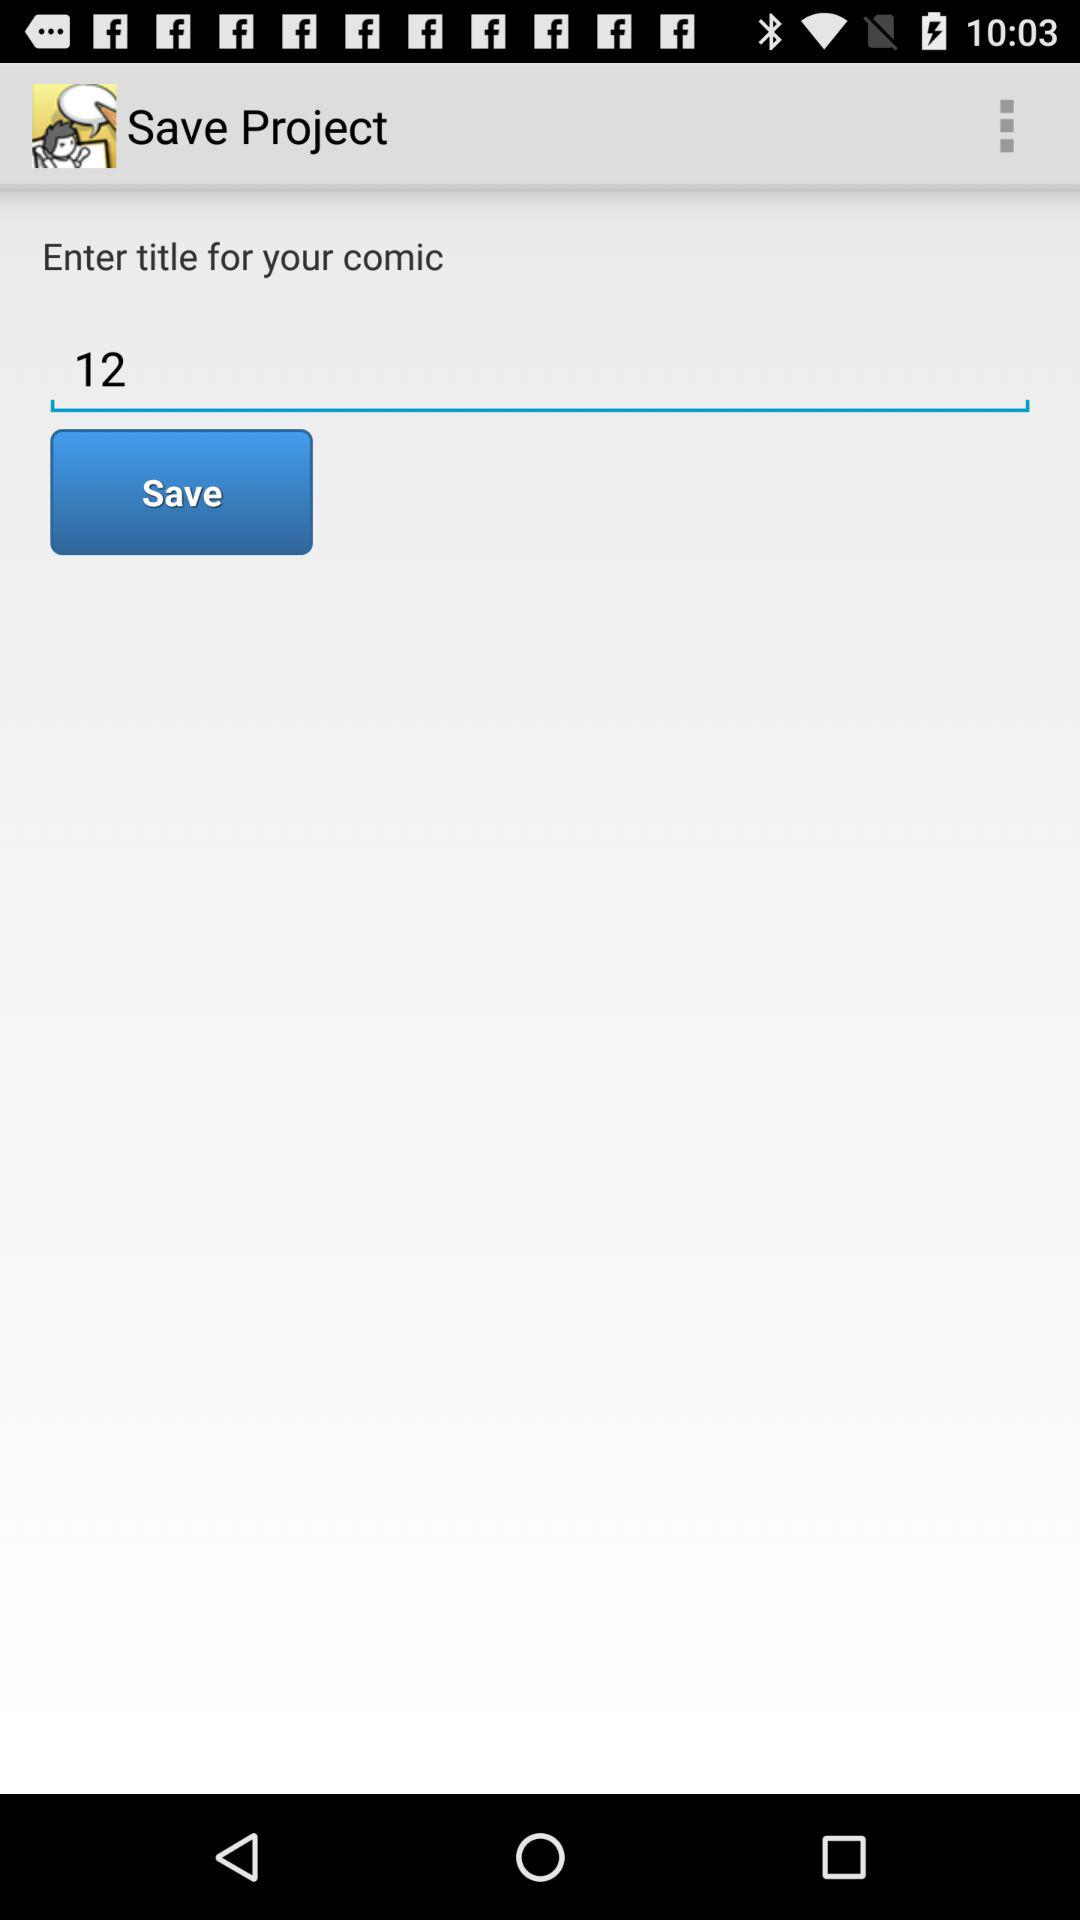What's the title entered for the comic? The title entered for the comic is "12". 